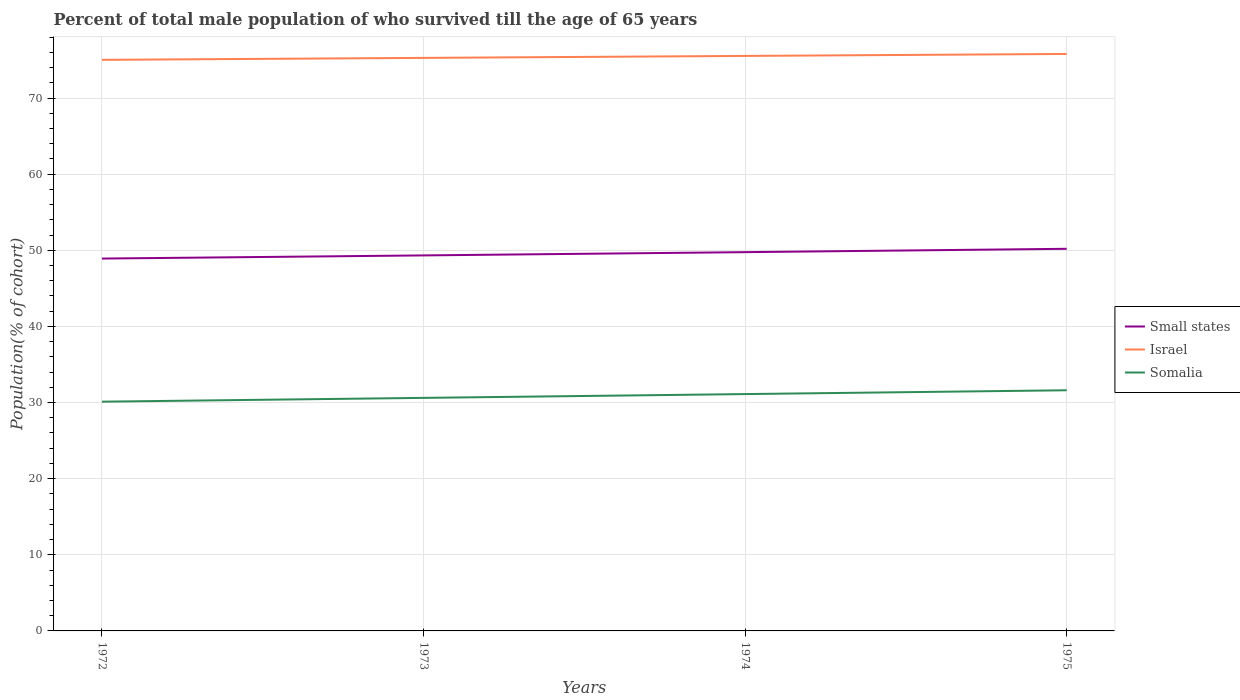How many different coloured lines are there?
Offer a very short reply. 3. Does the line corresponding to Small states intersect with the line corresponding to Israel?
Offer a very short reply. No. Across all years, what is the maximum percentage of total male population who survived till the age of 65 years in Small states?
Offer a very short reply. 48.91. What is the total percentage of total male population who survived till the age of 65 years in Israel in the graph?
Provide a short and direct response. -0.52. What is the difference between the highest and the second highest percentage of total male population who survived till the age of 65 years in Somalia?
Offer a terse response. 1.5. What is the difference between the highest and the lowest percentage of total male population who survived till the age of 65 years in Small states?
Offer a terse response. 2. How many lines are there?
Your answer should be very brief. 3. How many years are there in the graph?
Your answer should be very brief. 4. Does the graph contain any zero values?
Ensure brevity in your answer.  No. Where does the legend appear in the graph?
Provide a short and direct response. Center right. How many legend labels are there?
Your answer should be compact. 3. How are the legend labels stacked?
Ensure brevity in your answer.  Vertical. What is the title of the graph?
Ensure brevity in your answer.  Percent of total male population of who survived till the age of 65 years. Does "Zimbabwe" appear as one of the legend labels in the graph?
Ensure brevity in your answer.  No. What is the label or title of the Y-axis?
Your answer should be compact. Population(% of cohort). What is the Population(% of cohort) of Small states in 1972?
Your answer should be compact. 48.91. What is the Population(% of cohort) in Israel in 1972?
Give a very brief answer. 75.01. What is the Population(% of cohort) in Somalia in 1972?
Provide a short and direct response. 30.11. What is the Population(% of cohort) of Small states in 1973?
Your answer should be compact. 49.33. What is the Population(% of cohort) in Israel in 1973?
Keep it short and to the point. 75.27. What is the Population(% of cohort) of Somalia in 1973?
Keep it short and to the point. 30.61. What is the Population(% of cohort) in Small states in 1974?
Your response must be concise. 49.75. What is the Population(% of cohort) in Israel in 1974?
Make the answer very short. 75.53. What is the Population(% of cohort) of Somalia in 1974?
Provide a short and direct response. 31.11. What is the Population(% of cohort) in Small states in 1975?
Give a very brief answer. 50.19. What is the Population(% of cohort) in Israel in 1975?
Your answer should be very brief. 75.78. What is the Population(% of cohort) in Somalia in 1975?
Offer a very short reply. 31.61. Across all years, what is the maximum Population(% of cohort) of Small states?
Ensure brevity in your answer.  50.19. Across all years, what is the maximum Population(% of cohort) of Israel?
Your answer should be compact. 75.78. Across all years, what is the maximum Population(% of cohort) in Somalia?
Ensure brevity in your answer.  31.61. Across all years, what is the minimum Population(% of cohort) in Small states?
Your response must be concise. 48.91. Across all years, what is the minimum Population(% of cohort) of Israel?
Make the answer very short. 75.01. Across all years, what is the minimum Population(% of cohort) in Somalia?
Offer a very short reply. 30.11. What is the total Population(% of cohort) in Small states in the graph?
Offer a terse response. 198.18. What is the total Population(% of cohort) of Israel in the graph?
Provide a succinct answer. 301.59. What is the total Population(% of cohort) of Somalia in the graph?
Provide a succinct answer. 123.44. What is the difference between the Population(% of cohort) of Small states in 1972 and that in 1973?
Your answer should be compact. -0.42. What is the difference between the Population(% of cohort) in Israel in 1972 and that in 1973?
Ensure brevity in your answer.  -0.26. What is the difference between the Population(% of cohort) in Somalia in 1972 and that in 1973?
Offer a very short reply. -0.5. What is the difference between the Population(% of cohort) in Small states in 1972 and that in 1974?
Your response must be concise. -0.84. What is the difference between the Population(% of cohort) in Israel in 1972 and that in 1974?
Offer a very short reply. -0.52. What is the difference between the Population(% of cohort) in Somalia in 1972 and that in 1974?
Your answer should be compact. -1. What is the difference between the Population(% of cohort) of Small states in 1972 and that in 1975?
Offer a very short reply. -1.28. What is the difference between the Population(% of cohort) of Israel in 1972 and that in 1975?
Offer a very short reply. -0.77. What is the difference between the Population(% of cohort) in Somalia in 1972 and that in 1975?
Your answer should be very brief. -1.5. What is the difference between the Population(% of cohort) of Small states in 1973 and that in 1974?
Make the answer very short. -0.43. What is the difference between the Population(% of cohort) of Israel in 1973 and that in 1974?
Provide a succinct answer. -0.26. What is the difference between the Population(% of cohort) of Somalia in 1973 and that in 1974?
Give a very brief answer. -0.5. What is the difference between the Population(% of cohort) in Small states in 1973 and that in 1975?
Your answer should be compact. -0.87. What is the difference between the Population(% of cohort) in Israel in 1973 and that in 1975?
Keep it short and to the point. -0.52. What is the difference between the Population(% of cohort) in Somalia in 1973 and that in 1975?
Offer a terse response. -1. What is the difference between the Population(% of cohort) of Small states in 1974 and that in 1975?
Provide a short and direct response. -0.44. What is the difference between the Population(% of cohort) in Israel in 1974 and that in 1975?
Give a very brief answer. -0.26. What is the difference between the Population(% of cohort) in Somalia in 1974 and that in 1975?
Offer a terse response. -0.5. What is the difference between the Population(% of cohort) in Small states in 1972 and the Population(% of cohort) in Israel in 1973?
Provide a short and direct response. -26.36. What is the difference between the Population(% of cohort) of Small states in 1972 and the Population(% of cohort) of Somalia in 1973?
Provide a succinct answer. 18.3. What is the difference between the Population(% of cohort) in Israel in 1972 and the Population(% of cohort) in Somalia in 1973?
Offer a terse response. 44.4. What is the difference between the Population(% of cohort) of Small states in 1972 and the Population(% of cohort) of Israel in 1974?
Keep it short and to the point. -26.62. What is the difference between the Population(% of cohort) in Small states in 1972 and the Population(% of cohort) in Somalia in 1974?
Provide a short and direct response. 17.8. What is the difference between the Population(% of cohort) in Israel in 1972 and the Population(% of cohort) in Somalia in 1974?
Ensure brevity in your answer.  43.9. What is the difference between the Population(% of cohort) in Small states in 1972 and the Population(% of cohort) in Israel in 1975?
Your response must be concise. -26.87. What is the difference between the Population(% of cohort) of Small states in 1972 and the Population(% of cohort) of Somalia in 1975?
Ensure brevity in your answer.  17.3. What is the difference between the Population(% of cohort) of Israel in 1972 and the Population(% of cohort) of Somalia in 1975?
Offer a very short reply. 43.4. What is the difference between the Population(% of cohort) in Small states in 1973 and the Population(% of cohort) in Israel in 1974?
Provide a short and direct response. -26.2. What is the difference between the Population(% of cohort) of Small states in 1973 and the Population(% of cohort) of Somalia in 1974?
Provide a short and direct response. 18.21. What is the difference between the Population(% of cohort) in Israel in 1973 and the Population(% of cohort) in Somalia in 1974?
Give a very brief answer. 44.16. What is the difference between the Population(% of cohort) in Small states in 1973 and the Population(% of cohort) in Israel in 1975?
Provide a short and direct response. -26.46. What is the difference between the Population(% of cohort) of Small states in 1973 and the Population(% of cohort) of Somalia in 1975?
Your answer should be very brief. 17.72. What is the difference between the Population(% of cohort) of Israel in 1973 and the Population(% of cohort) of Somalia in 1975?
Make the answer very short. 43.66. What is the difference between the Population(% of cohort) in Small states in 1974 and the Population(% of cohort) in Israel in 1975?
Your answer should be compact. -26.03. What is the difference between the Population(% of cohort) in Small states in 1974 and the Population(% of cohort) in Somalia in 1975?
Keep it short and to the point. 18.14. What is the difference between the Population(% of cohort) in Israel in 1974 and the Population(% of cohort) in Somalia in 1975?
Your answer should be very brief. 43.92. What is the average Population(% of cohort) in Small states per year?
Offer a very short reply. 49.54. What is the average Population(% of cohort) in Israel per year?
Give a very brief answer. 75.4. What is the average Population(% of cohort) in Somalia per year?
Ensure brevity in your answer.  30.86. In the year 1972, what is the difference between the Population(% of cohort) of Small states and Population(% of cohort) of Israel?
Give a very brief answer. -26.1. In the year 1972, what is the difference between the Population(% of cohort) of Small states and Population(% of cohort) of Somalia?
Ensure brevity in your answer.  18.8. In the year 1972, what is the difference between the Population(% of cohort) of Israel and Population(% of cohort) of Somalia?
Give a very brief answer. 44.9. In the year 1973, what is the difference between the Population(% of cohort) in Small states and Population(% of cohort) in Israel?
Keep it short and to the point. -25.94. In the year 1973, what is the difference between the Population(% of cohort) of Small states and Population(% of cohort) of Somalia?
Ensure brevity in your answer.  18.71. In the year 1973, what is the difference between the Population(% of cohort) of Israel and Population(% of cohort) of Somalia?
Provide a succinct answer. 44.66. In the year 1974, what is the difference between the Population(% of cohort) in Small states and Population(% of cohort) in Israel?
Provide a short and direct response. -25.78. In the year 1974, what is the difference between the Population(% of cohort) of Small states and Population(% of cohort) of Somalia?
Keep it short and to the point. 18.64. In the year 1974, what is the difference between the Population(% of cohort) in Israel and Population(% of cohort) in Somalia?
Offer a terse response. 44.42. In the year 1975, what is the difference between the Population(% of cohort) of Small states and Population(% of cohort) of Israel?
Offer a very short reply. -25.59. In the year 1975, what is the difference between the Population(% of cohort) of Small states and Population(% of cohort) of Somalia?
Your answer should be compact. 18.58. In the year 1975, what is the difference between the Population(% of cohort) of Israel and Population(% of cohort) of Somalia?
Provide a succinct answer. 44.17. What is the ratio of the Population(% of cohort) of Small states in 1972 to that in 1973?
Offer a terse response. 0.99. What is the ratio of the Population(% of cohort) of Israel in 1972 to that in 1973?
Offer a terse response. 1. What is the ratio of the Population(% of cohort) of Somalia in 1972 to that in 1973?
Keep it short and to the point. 0.98. What is the ratio of the Population(% of cohort) of Small states in 1972 to that in 1974?
Your response must be concise. 0.98. What is the ratio of the Population(% of cohort) of Somalia in 1972 to that in 1974?
Offer a very short reply. 0.97. What is the ratio of the Population(% of cohort) in Small states in 1972 to that in 1975?
Offer a very short reply. 0.97. What is the ratio of the Population(% of cohort) in Israel in 1972 to that in 1975?
Provide a short and direct response. 0.99. What is the ratio of the Population(% of cohort) of Somalia in 1972 to that in 1975?
Make the answer very short. 0.95. What is the ratio of the Population(% of cohort) of Small states in 1973 to that in 1974?
Provide a short and direct response. 0.99. What is the ratio of the Population(% of cohort) of Somalia in 1973 to that in 1974?
Offer a terse response. 0.98. What is the ratio of the Population(% of cohort) of Small states in 1973 to that in 1975?
Keep it short and to the point. 0.98. What is the ratio of the Population(% of cohort) of Somalia in 1973 to that in 1975?
Offer a terse response. 0.97. What is the ratio of the Population(% of cohort) in Small states in 1974 to that in 1975?
Provide a succinct answer. 0.99. What is the ratio of the Population(% of cohort) in Somalia in 1974 to that in 1975?
Ensure brevity in your answer.  0.98. What is the difference between the highest and the second highest Population(% of cohort) in Small states?
Offer a very short reply. 0.44. What is the difference between the highest and the second highest Population(% of cohort) of Israel?
Keep it short and to the point. 0.26. What is the difference between the highest and the second highest Population(% of cohort) in Somalia?
Keep it short and to the point. 0.5. What is the difference between the highest and the lowest Population(% of cohort) of Small states?
Keep it short and to the point. 1.28. What is the difference between the highest and the lowest Population(% of cohort) in Israel?
Give a very brief answer. 0.77. What is the difference between the highest and the lowest Population(% of cohort) in Somalia?
Keep it short and to the point. 1.5. 